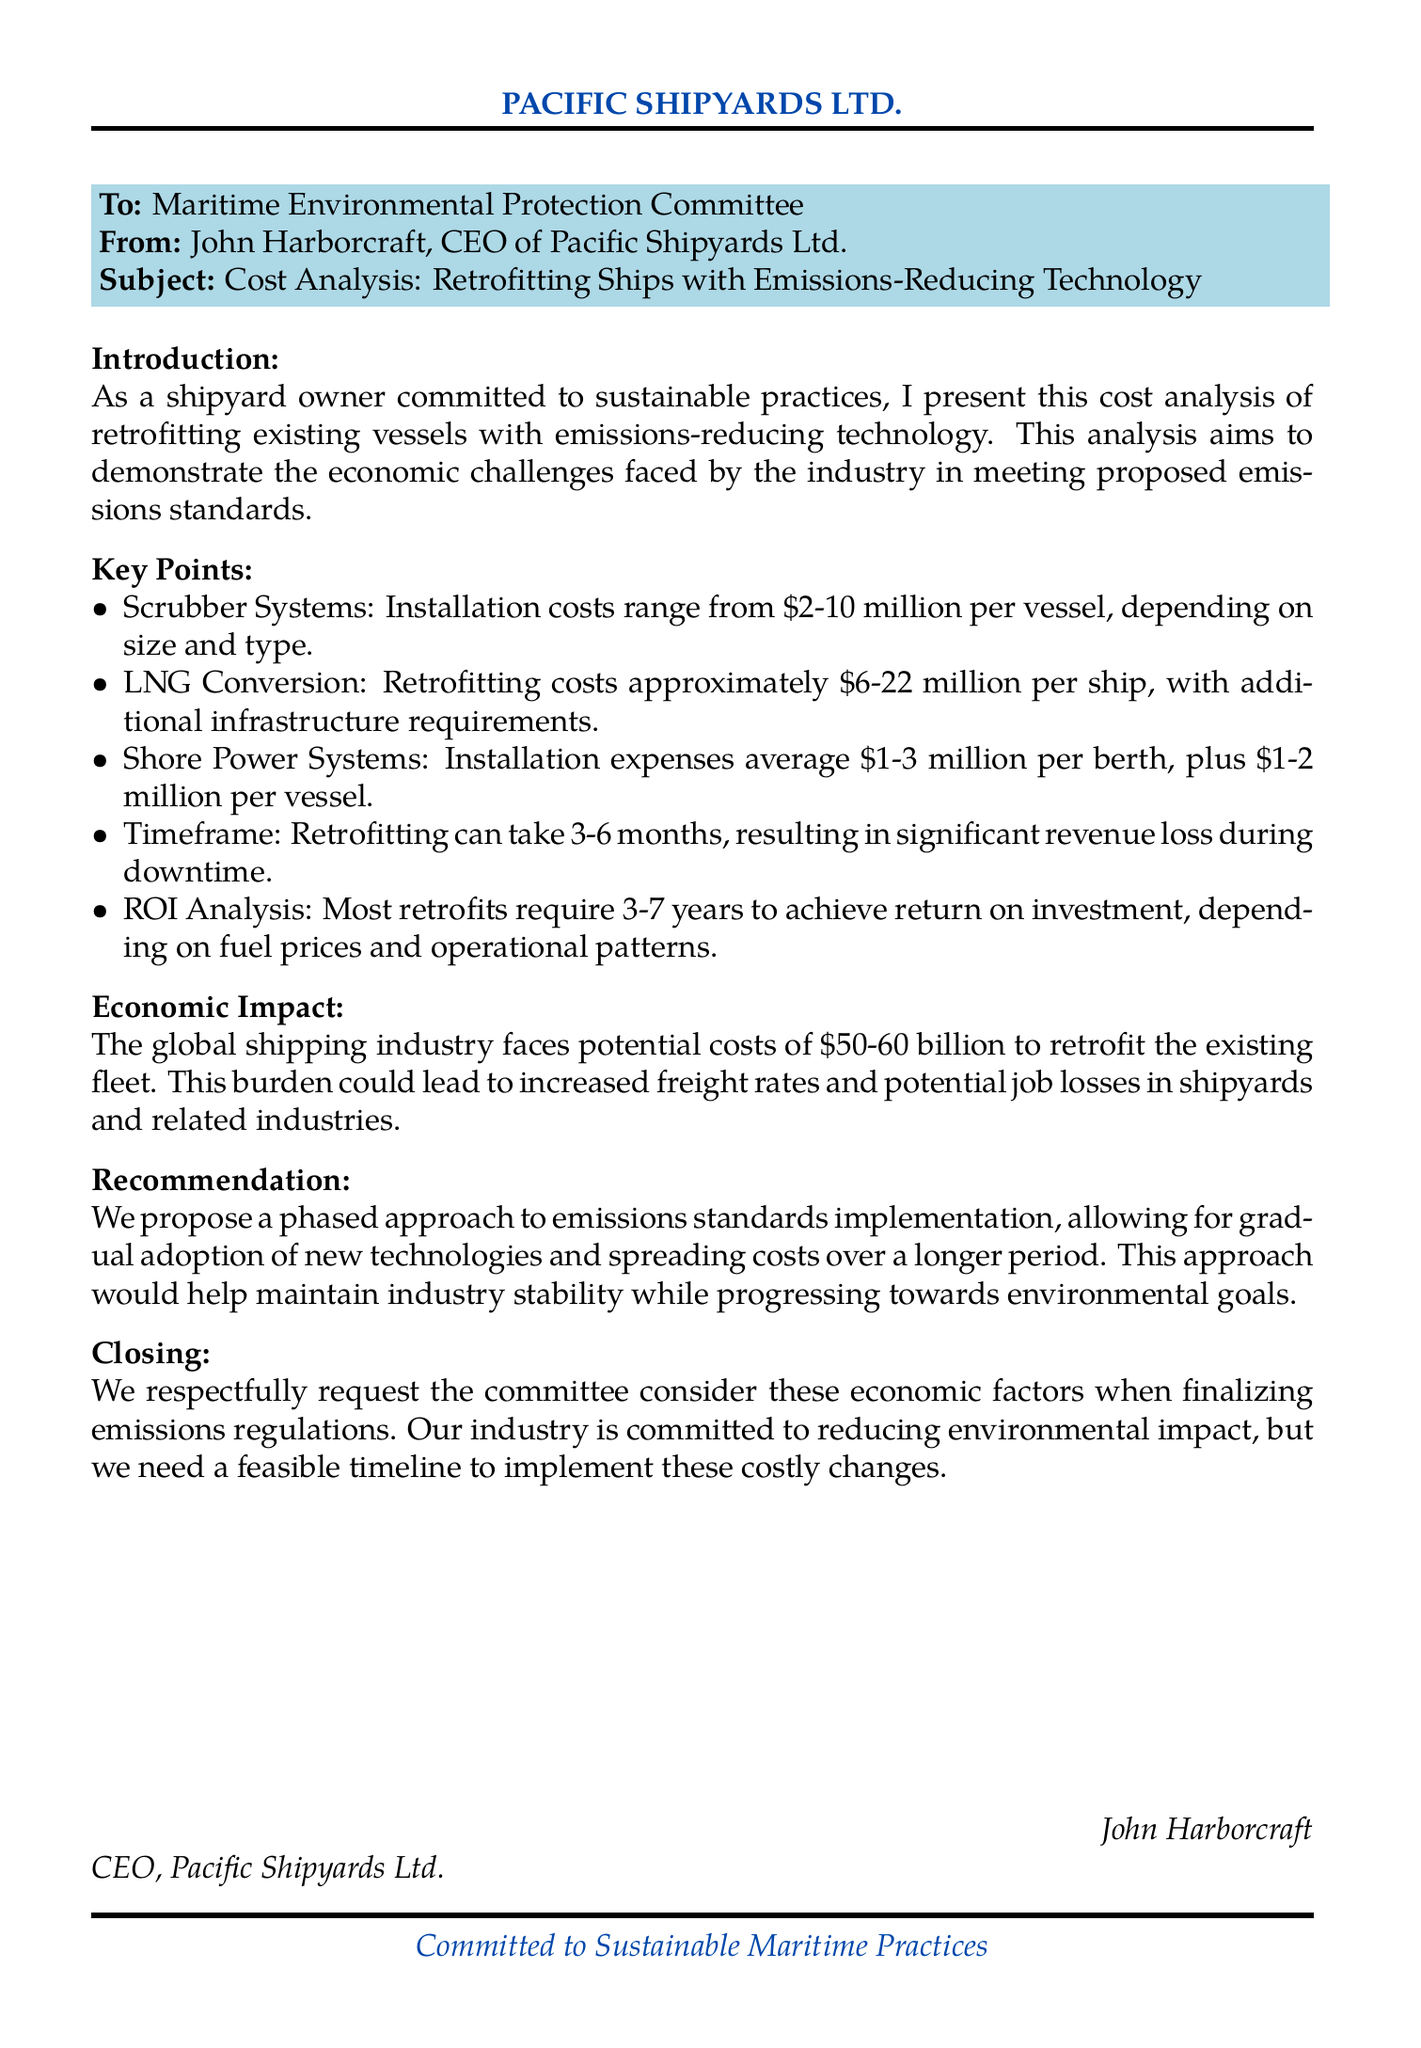What is the subject of the fax? The subject line clearly states the topic of discussion in the document.
Answer: Cost Analysis: Retrofitting Ships with Emissions-Reducing Technology Who is the sender of the fax? The sender's name and title are mentioned in the document's header.
Answer: John Harborcraft, CEO of Pacific Shipyards Ltd What is the installation cost range for scrubber systems? The document specifies a cost range for this particular technology.
Answer: $2-10 million What is the average installation expense for shore power systems per berth? The document provides a specific financial figure for the installation of shore power systems.
Answer: $1-3 million How long does retrofitting typically take? The document indicates the time required for the retrofitting process.
Answer: 3-6 months What is the proposed approach to emissions standards implementation? The recommendation section outlines a specific strategy for implementing standards.
Answer: Phased approach What is the estimated global cost to retrofit the existing fleet? The document mentions the total potential cost indicating the broader impact on the industry.
Answer: $50-60 billion What is the return on investment (ROI) time frame for most retrofits? The document specifies the time required to achieve ROI for retrofitting investments.
Answer: 3-7 years 